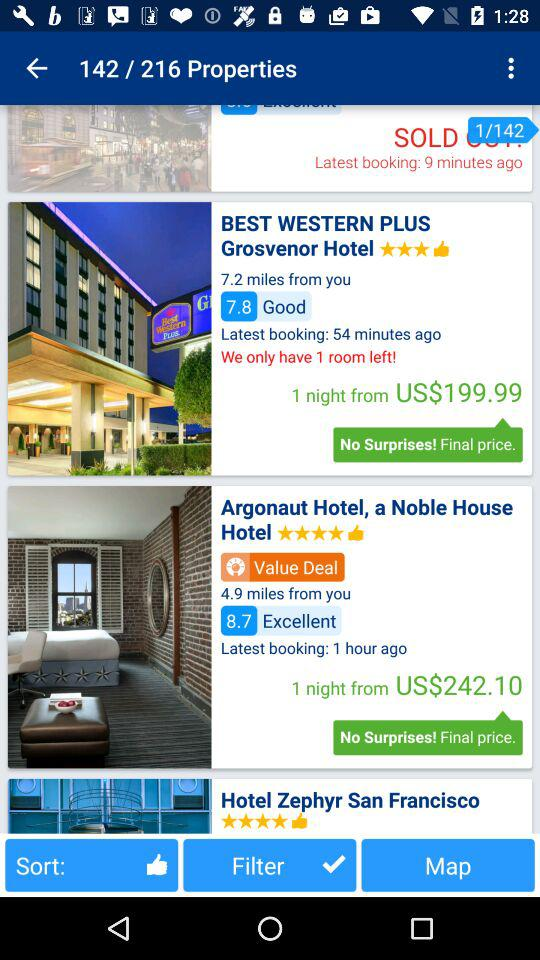How many properties are there in total?
Answer the question using a single word or phrase. 216 